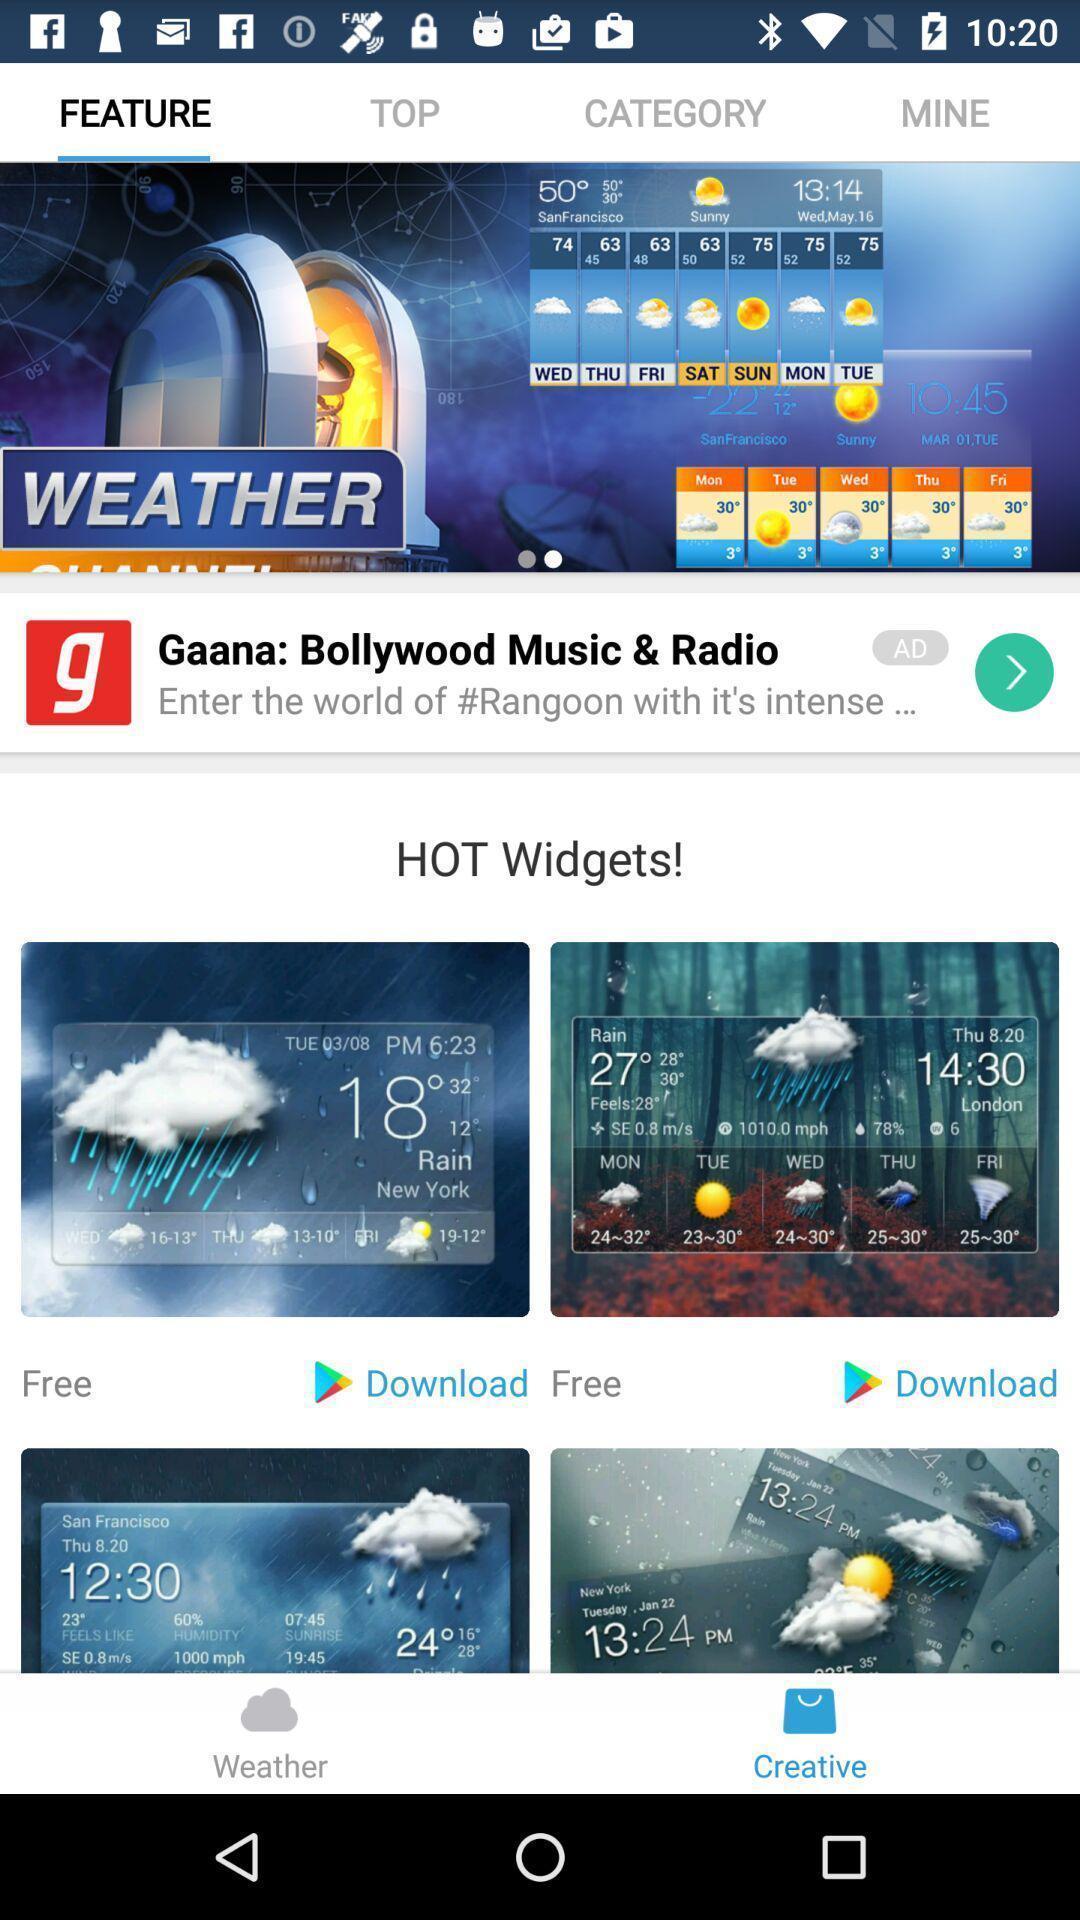Provide a detailed account of this screenshot. Page showing whether information. 